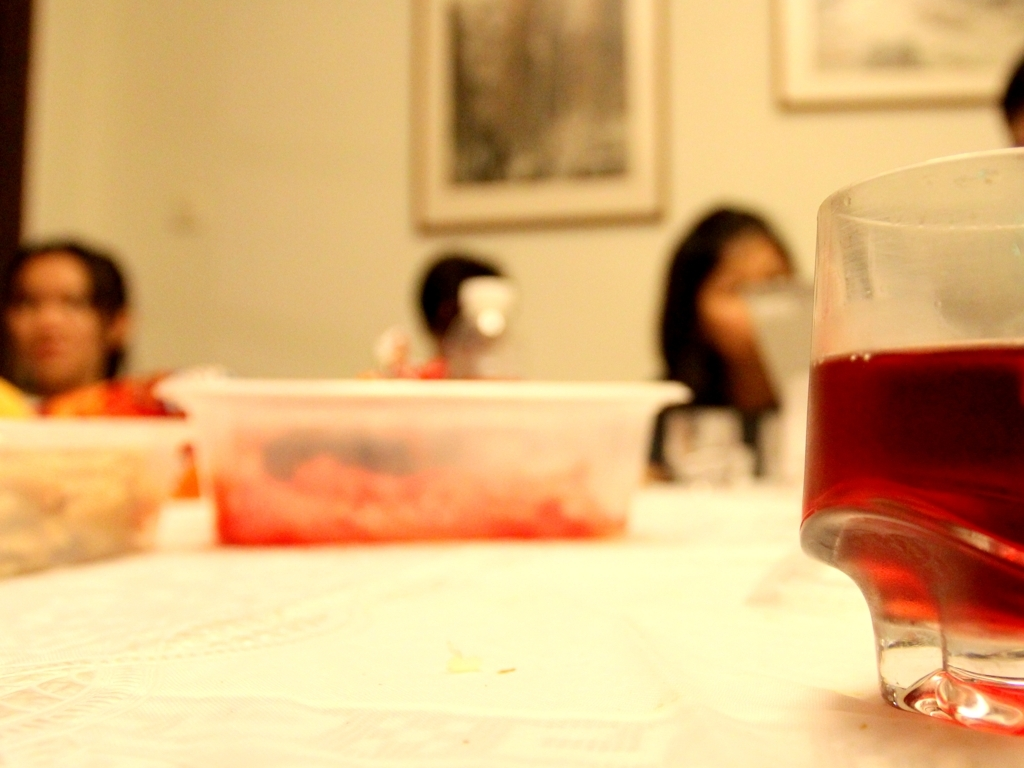Can you describe the drink in the glass? The glass in the foreground contains a dark reddish beverage with a translucent quality, suggesting it could be a type of juice or a soft drink. The way it catches the light hints at its possibly refreshing nature. What kind of mood does the image convey? The image evokes a relaxed and convivial ambiance, likely a gathering of friends or family enjoying each other's company. The warm tones and soft focus contribute to the sense of an informal and cozy setting. 